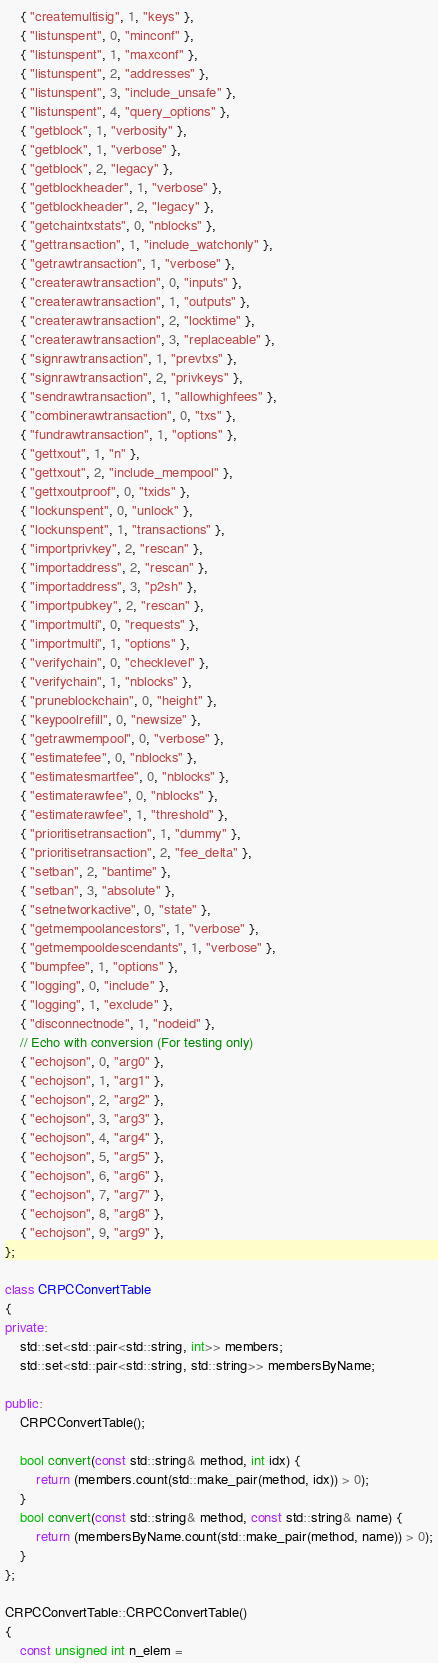Convert code to text. <code><loc_0><loc_0><loc_500><loc_500><_C++_>    { "createmultisig", 1, "keys" },
    { "listunspent", 0, "minconf" },
    { "listunspent", 1, "maxconf" },
    { "listunspent", 2, "addresses" },
    { "listunspent", 3, "include_unsafe" },
    { "listunspent", 4, "query_options" },
    { "getblock", 1, "verbosity" },
    { "getblock", 1, "verbose" },
    { "getblock", 2, "legacy" },
    { "getblockheader", 1, "verbose" },
    { "getblockheader", 2, "legacy" },
    { "getchaintxstats", 0, "nblocks" },
    { "gettransaction", 1, "include_watchonly" },
    { "getrawtransaction", 1, "verbose" },
    { "createrawtransaction", 0, "inputs" },
    { "createrawtransaction", 1, "outputs" },
    { "createrawtransaction", 2, "locktime" },
    { "createrawtransaction", 3, "replaceable" },
    { "signrawtransaction", 1, "prevtxs" },
    { "signrawtransaction", 2, "privkeys" },
    { "sendrawtransaction", 1, "allowhighfees" },
    { "combinerawtransaction", 0, "txs" },
    { "fundrawtransaction", 1, "options" },
    { "gettxout", 1, "n" },
    { "gettxout", 2, "include_mempool" },
    { "gettxoutproof", 0, "txids" },
    { "lockunspent", 0, "unlock" },
    { "lockunspent", 1, "transactions" },
    { "importprivkey", 2, "rescan" },
    { "importaddress", 2, "rescan" },
    { "importaddress", 3, "p2sh" },
    { "importpubkey", 2, "rescan" },
    { "importmulti", 0, "requests" },
    { "importmulti", 1, "options" },
    { "verifychain", 0, "checklevel" },
    { "verifychain", 1, "nblocks" },
    { "pruneblockchain", 0, "height" },
    { "keypoolrefill", 0, "newsize" },
    { "getrawmempool", 0, "verbose" },
    { "estimatefee", 0, "nblocks" },
    { "estimatesmartfee", 0, "nblocks" },
    { "estimaterawfee", 0, "nblocks" },
    { "estimaterawfee", 1, "threshold" },
    { "prioritisetransaction", 1, "dummy" },
    { "prioritisetransaction", 2, "fee_delta" },
    { "setban", 2, "bantime" },
    { "setban", 3, "absolute" },
    { "setnetworkactive", 0, "state" },
    { "getmempoolancestors", 1, "verbose" },
    { "getmempooldescendants", 1, "verbose" },
    { "bumpfee", 1, "options" },
    { "logging", 0, "include" },
    { "logging", 1, "exclude" },
    { "disconnectnode", 1, "nodeid" },
    // Echo with conversion (For testing only)
    { "echojson", 0, "arg0" },
    { "echojson", 1, "arg1" },
    { "echojson", 2, "arg2" },
    { "echojson", 3, "arg3" },
    { "echojson", 4, "arg4" },
    { "echojson", 5, "arg5" },
    { "echojson", 6, "arg6" },
    { "echojson", 7, "arg7" },
    { "echojson", 8, "arg8" },
    { "echojson", 9, "arg9" },
};

class CRPCConvertTable
{
private:
    std::set<std::pair<std::string, int>> members;
    std::set<std::pair<std::string, std::string>> membersByName;

public:
    CRPCConvertTable();

    bool convert(const std::string& method, int idx) {
        return (members.count(std::make_pair(method, idx)) > 0);
    }
    bool convert(const std::string& method, const std::string& name) {
        return (membersByName.count(std::make_pair(method, name)) > 0);
    }
};

CRPCConvertTable::CRPCConvertTable()
{
    const unsigned int n_elem =</code> 